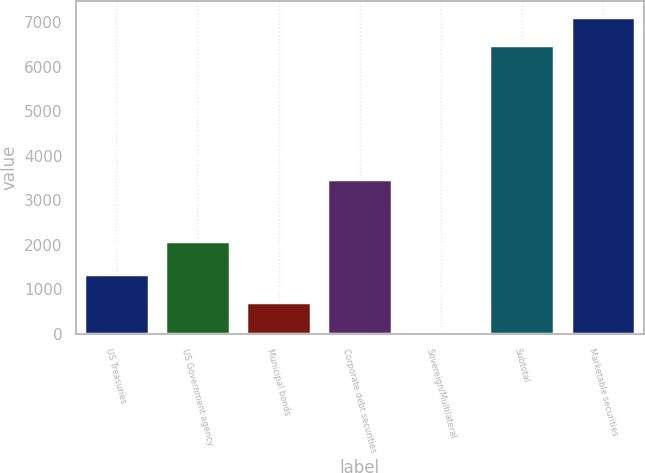Convert chart. <chart><loc_0><loc_0><loc_500><loc_500><bar_chart><fcel>US Treasuries<fcel>US Government agency<fcel>Municipal bonds<fcel>Corporate debt securities<fcel>Sovereign/Multilateral<fcel>Subtotal<fcel>Marketable securities<nl><fcel>1353.6<fcel>2089<fcel>713.3<fcel>3478<fcel>73<fcel>6476<fcel>7116.3<nl></chart> 